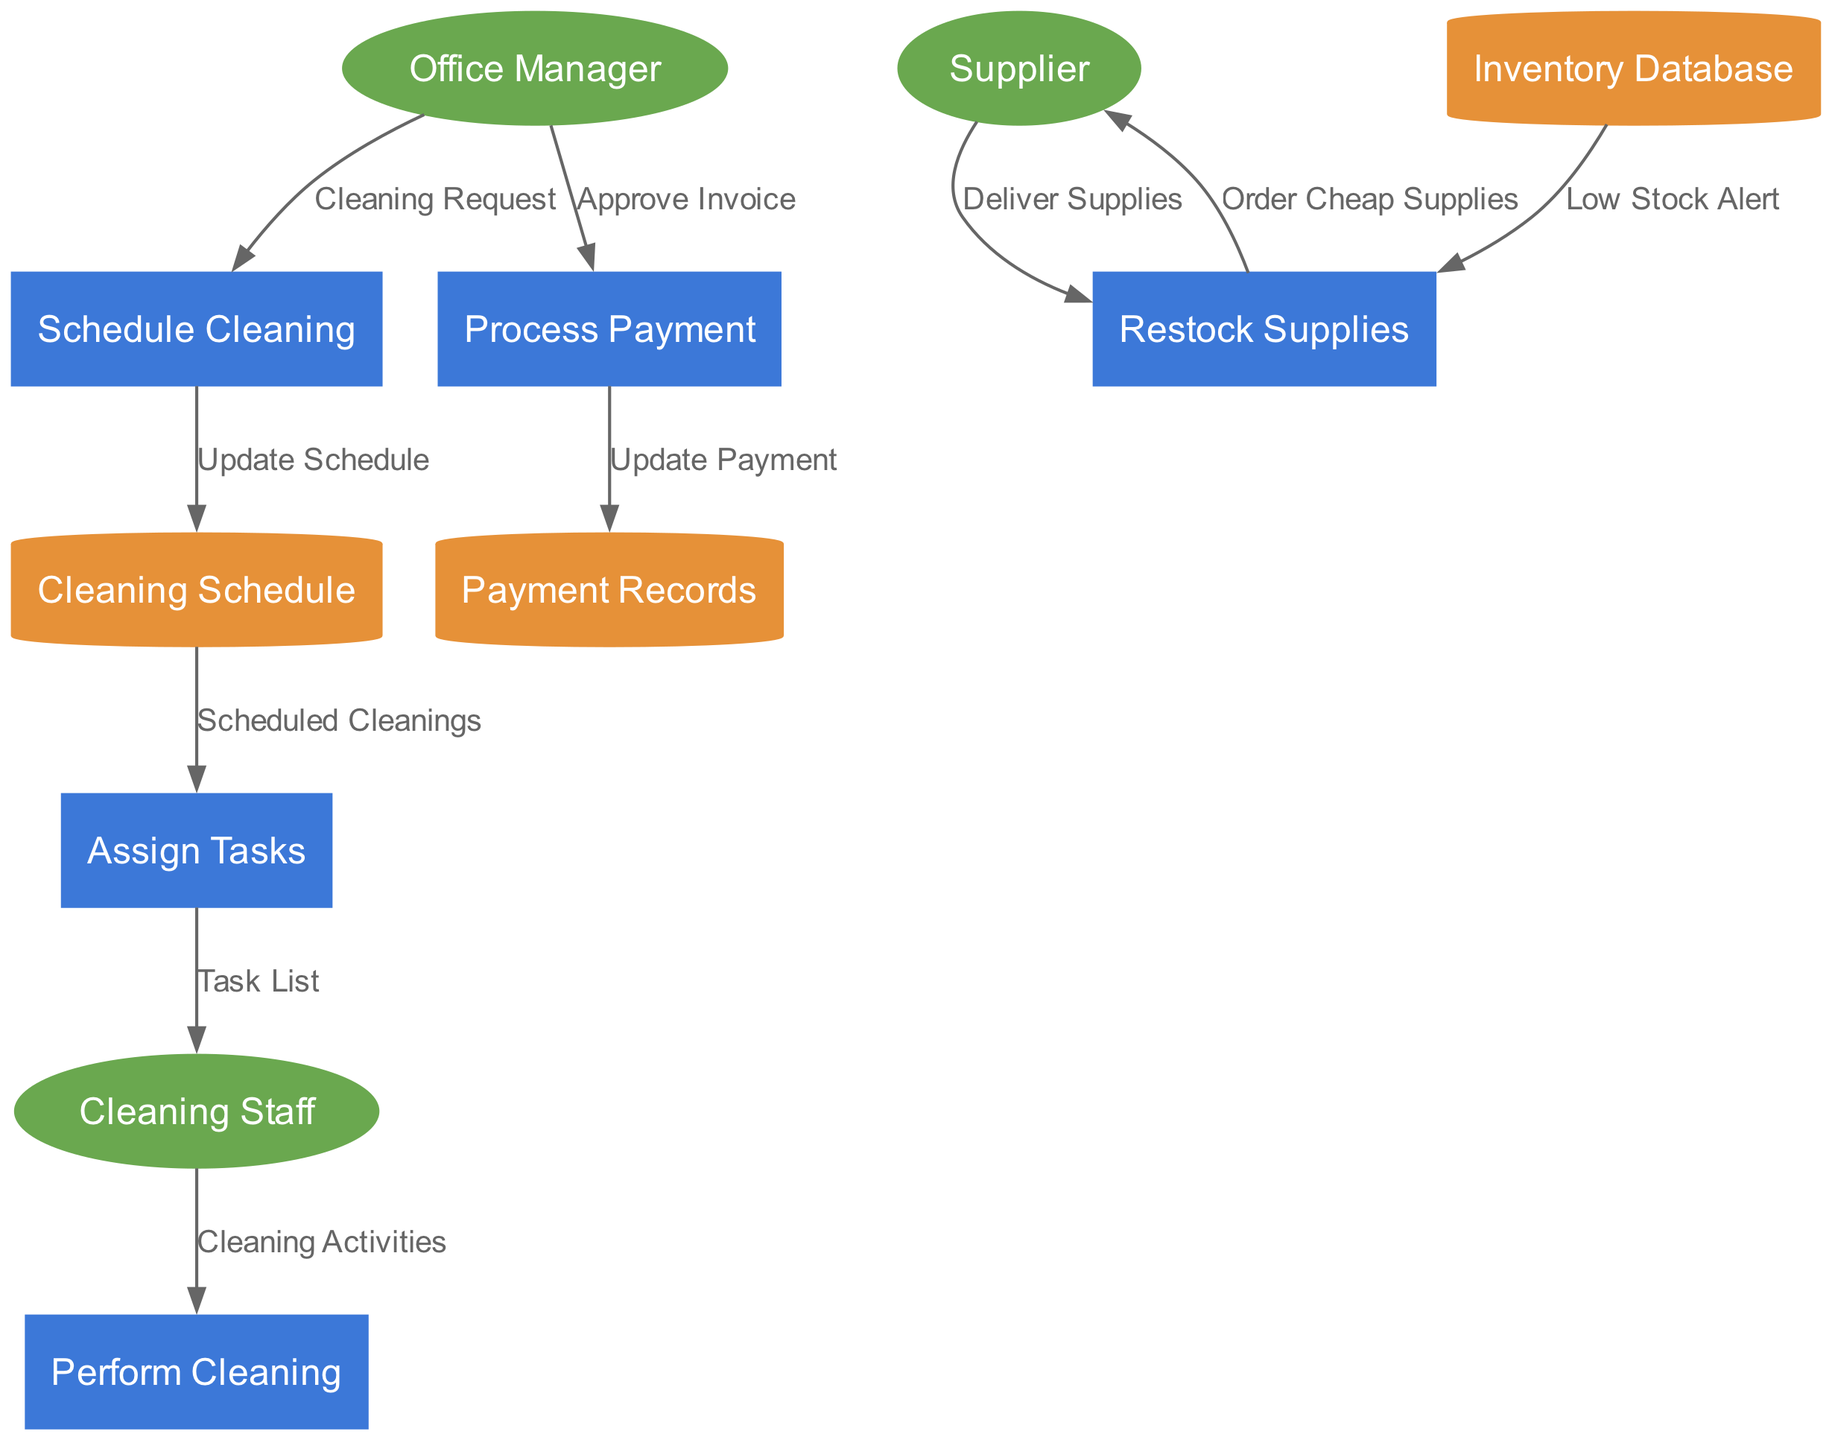What is the first process initiated by the Office Manager? The first process initiated by the Office Manager, as indicated in the data flow, is "Schedule Cleaning". This process is directly preceded by the "Cleaning Request" flow from the Office Manager.
Answer: Schedule Cleaning How many external entities are represented in the diagram? The diagram shows three external entities: Office Manager, Cleaning Staff, and Supplier. This can be confirmed by counting the respective shapes in the diagram.
Answer: 3 What data flow represents the delivery of supplies? The flow that represents the delivery of supplies exists between the Supplier and Restock Supplies, labeled as "Deliver Supplies". This indicates the direction of information exchange about supplies.
Answer: Deliver Supplies Which process updates the cleaning schedule? The process that updates the cleaning schedule is "Schedule Cleaning". It receives input from the Office Manager's cleaning request and outputs to the "Cleaning Schedule" data store.
Answer: Schedule Cleaning What data store is updated after processing the payment? After the payment is processed, the data store that is updated is "Payment Records". This occurs as part of the "Process Payment" process, showing the flow of information regarding financial transactions.
Answer: Payment Records What is the last step in the cleaning workflow? The last step in the cleaning workflow is "Process Payment". The flow sequence reveals that after all cleaning activities and tasks, the final step involves payment actions.
Answer: Process Payment Which entity provides supplies when stock is low? The entity that provides supplies when stock is low is the Supplier. The process "Restock Supplies" initiates an order to the Supplier when alerted by the "Low Stock Alert" from the Inventory Database.
Answer: Supplier How does cleaning staff receive their tasks? The cleaning staff receive their tasks through the data flow labeled "Task List" coming from the "Assign Tasks" process. This indicates that tasks are specifically generated and given to the staff members.
Answer: Task List Which entity approves the invoice for payment? The entity responsible for approving the invoice for payment is the Office Manager. This is shown in the flow that goes from the Office Manager to the "Process Payment" process.
Answer: Office Manager 